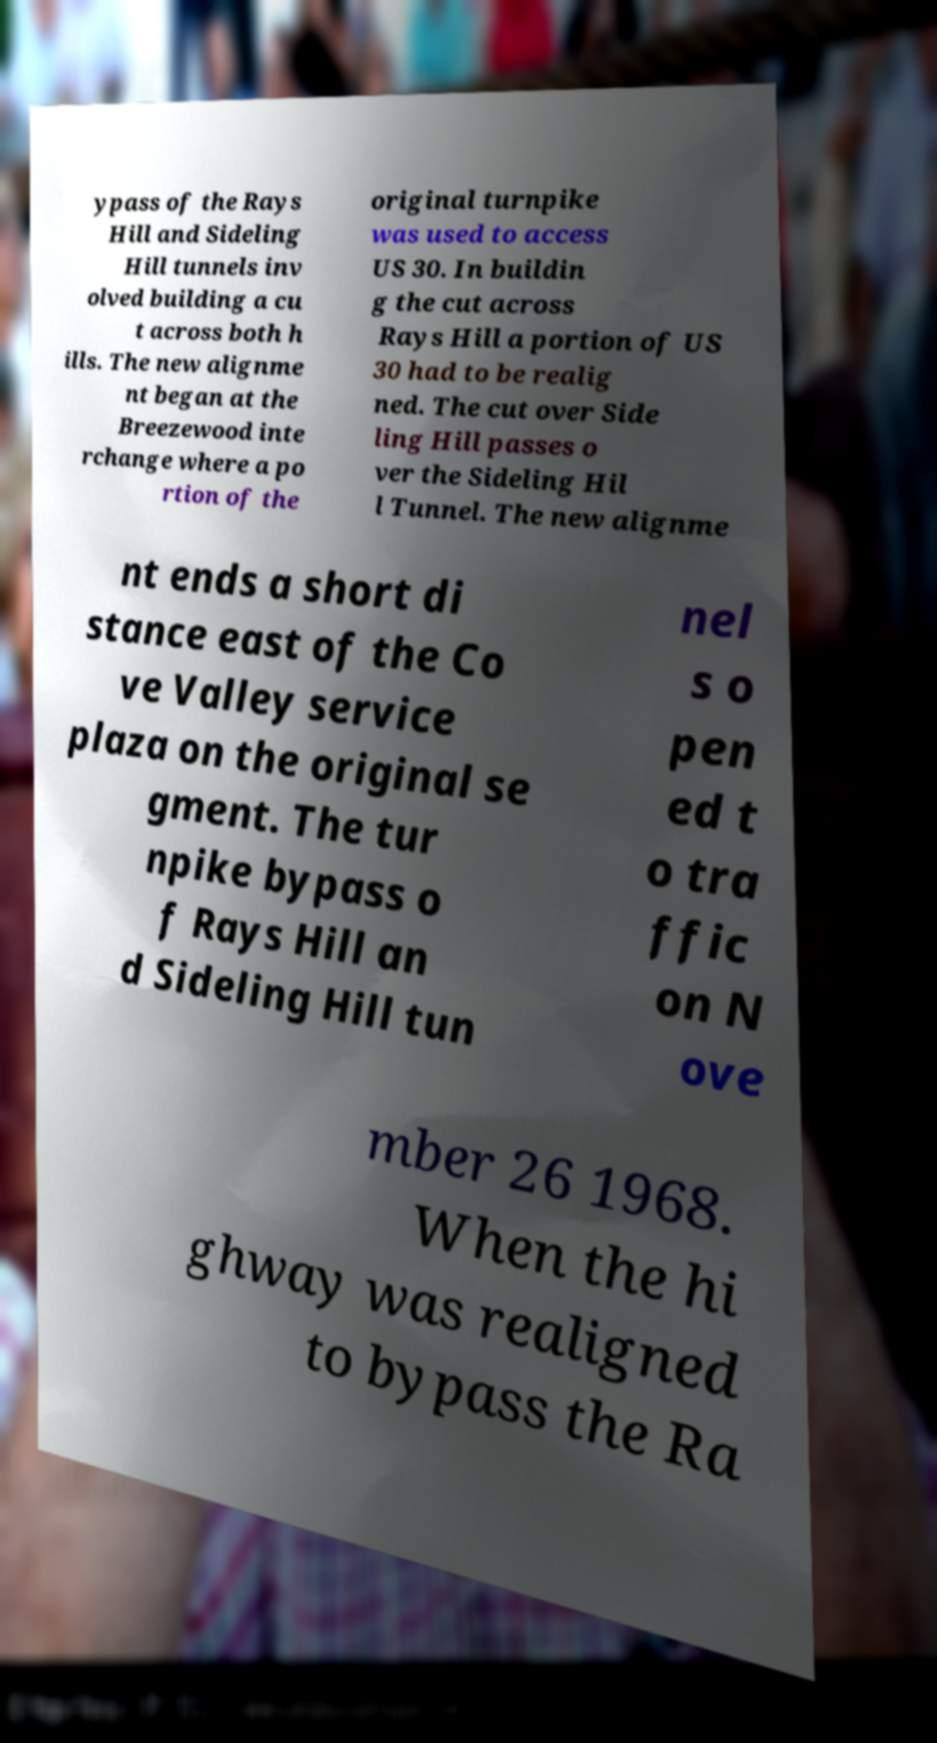Can you read and provide the text displayed in the image?This photo seems to have some interesting text. Can you extract and type it out for me? ypass of the Rays Hill and Sideling Hill tunnels inv olved building a cu t across both h ills. The new alignme nt began at the Breezewood inte rchange where a po rtion of the original turnpike was used to access US 30. In buildin g the cut across Rays Hill a portion of US 30 had to be realig ned. The cut over Side ling Hill passes o ver the Sideling Hil l Tunnel. The new alignme nt ends a short di stance east of the Co ve Valley service plaza on the original se gment. The tur npike bypass o f Rays Hill an d Sideling Hill tun nel s o pen ed t o tra ffic on N ove mber 26 1968. When the hi ghway was realigned to bypass the Ra 